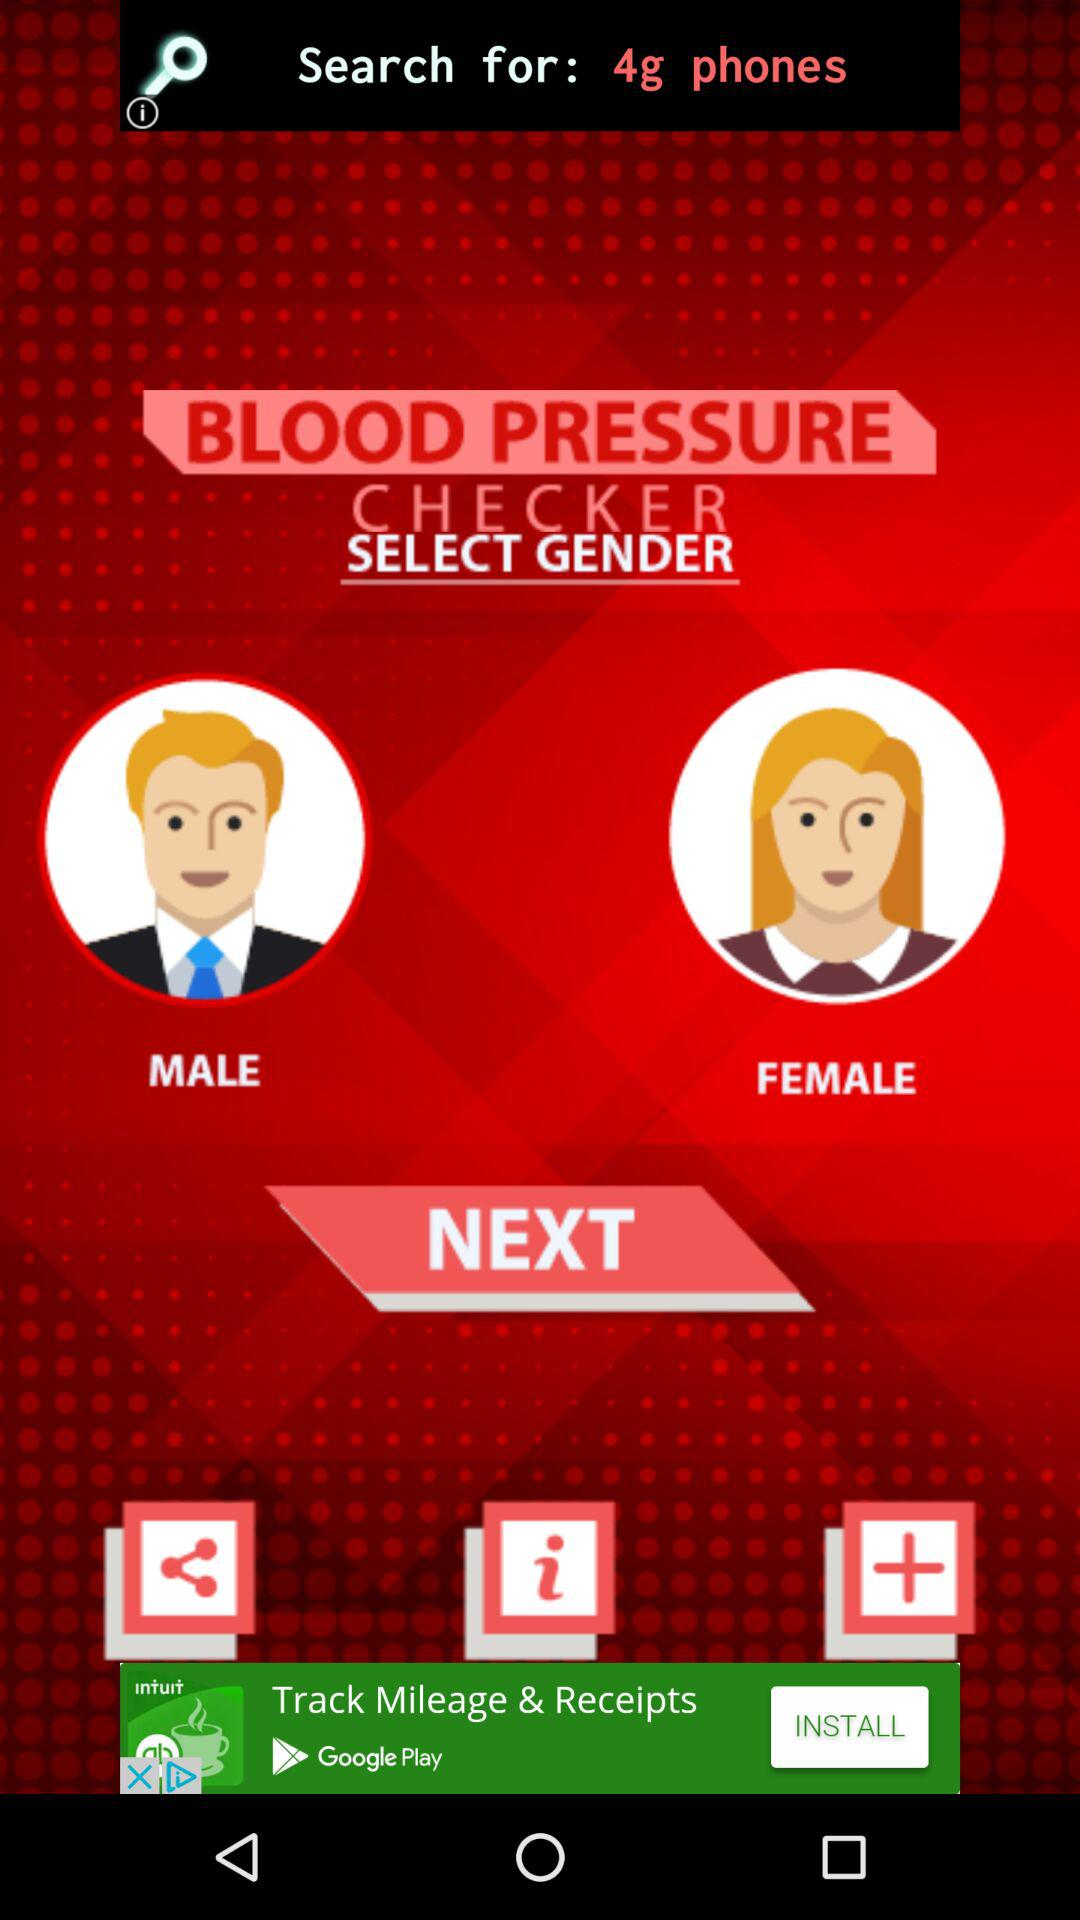What is the name of the application? The name of the application is "BLOOD PRESSURE CHECKER". 